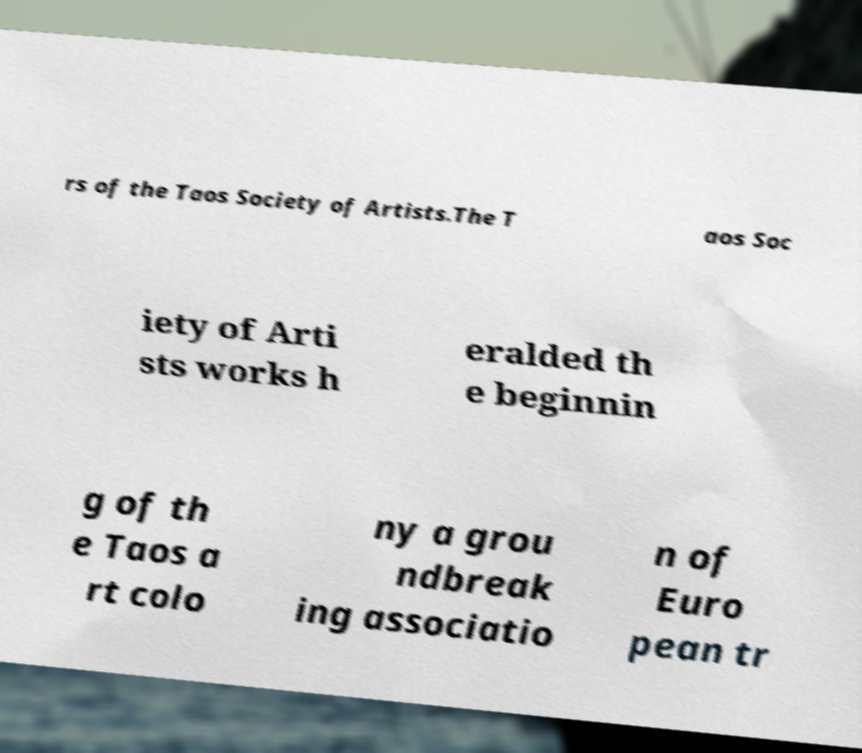Can you read and provide the text displayed in the image?This photo seems to have some interesting text. Can you extract and type it out for me? rs of the Taos Society of Artists.The T aos Soc iety of Arti sts works h eralded th e beginnin g of th e Taos a rt colo ny a grou ndbreak ing associatio n of Euro pean tr 